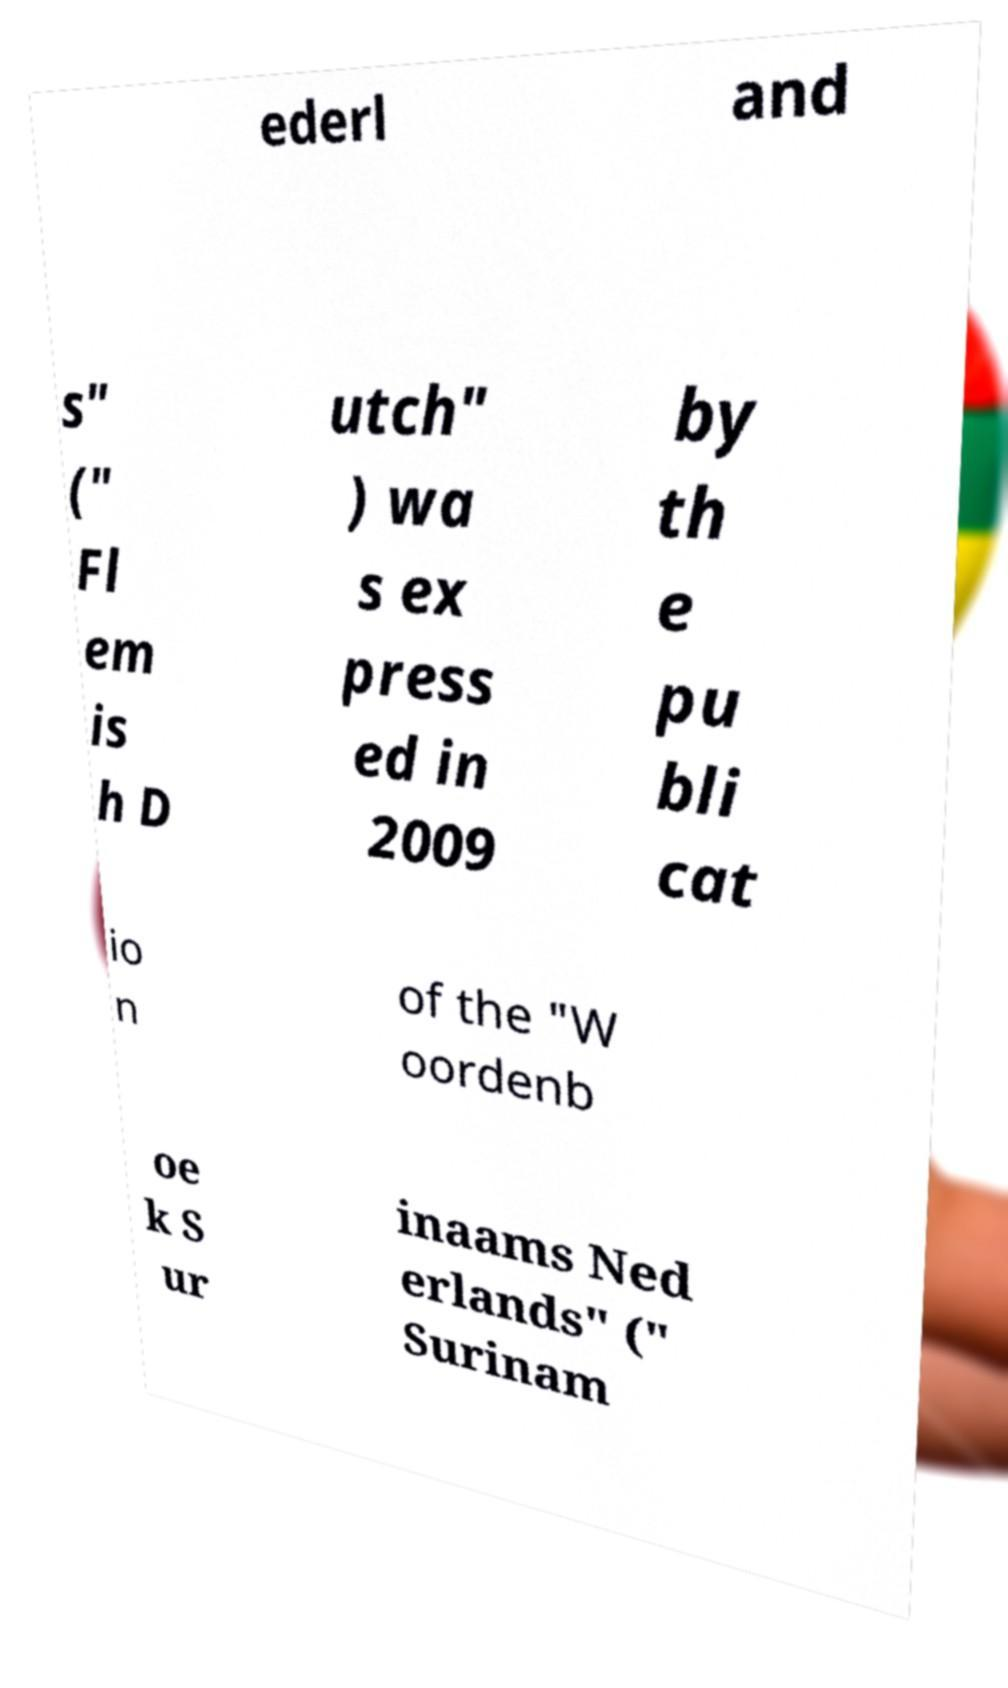Can you accurately transcribe the text from the provided image for me? ederl and s" (" Fl em is h D utch" ) wa s ex press ed in 2009 by th e pu bli cat io n of the "W oordenb oe k S ur inaams Ned erlands" (" Surinam 